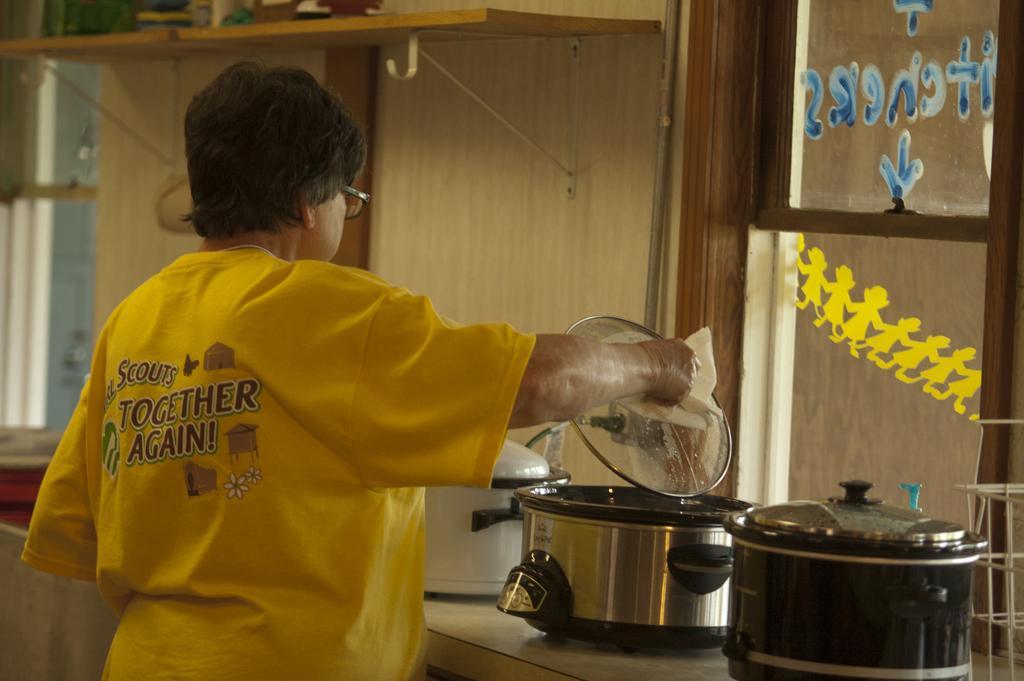Please provide a concise description of this image. On the right side of the image there is a table. On the table we can see vessels with lid, window, glass. In the center of the image a lady is standing and holding a lid with cloth. In the background of the image we can see wall and some objects, shelf. 